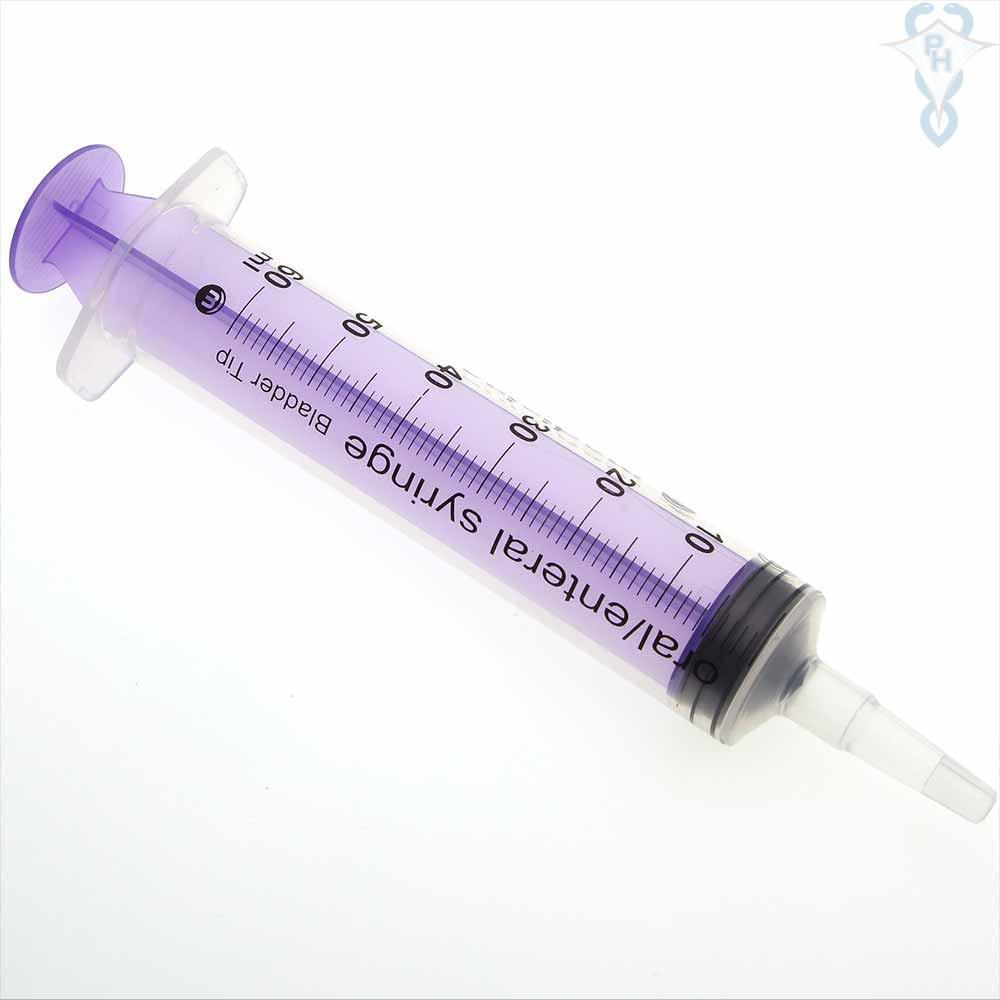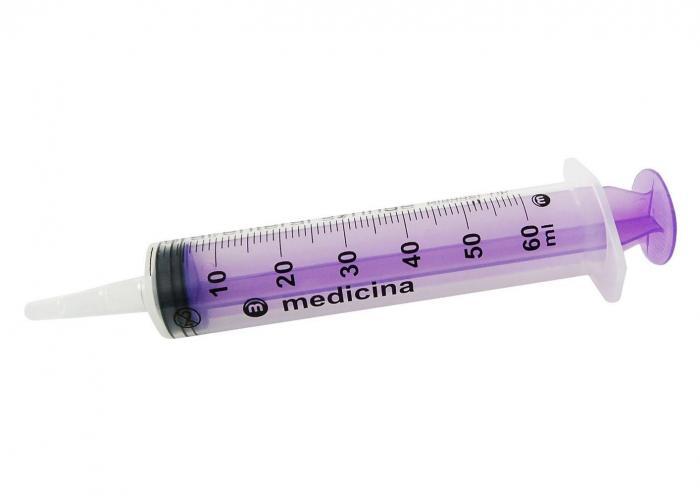The first image is the image on the left, the second image is the image on the right. Examine the images to the left and right. Is the description "Both syringes are exactly horizontal." accurate? Answer yes or no. No. 